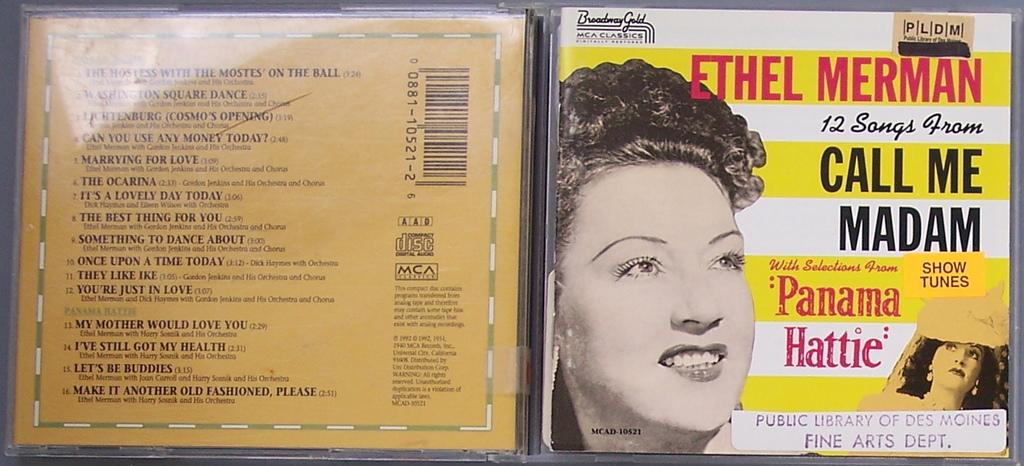What type of image is being described? The image is a collage. What can be found within the collage? There are pictures of people in the collage. Are there any words or phrases in the collage? Yes, there is text present in the collage. Can you see a thumb in the collage? There is no thumb present in the collage; it contains pictures of people and text. What type of beast is depicted in the collage? There is no beast present in the collage; it features pictures of people and text. 